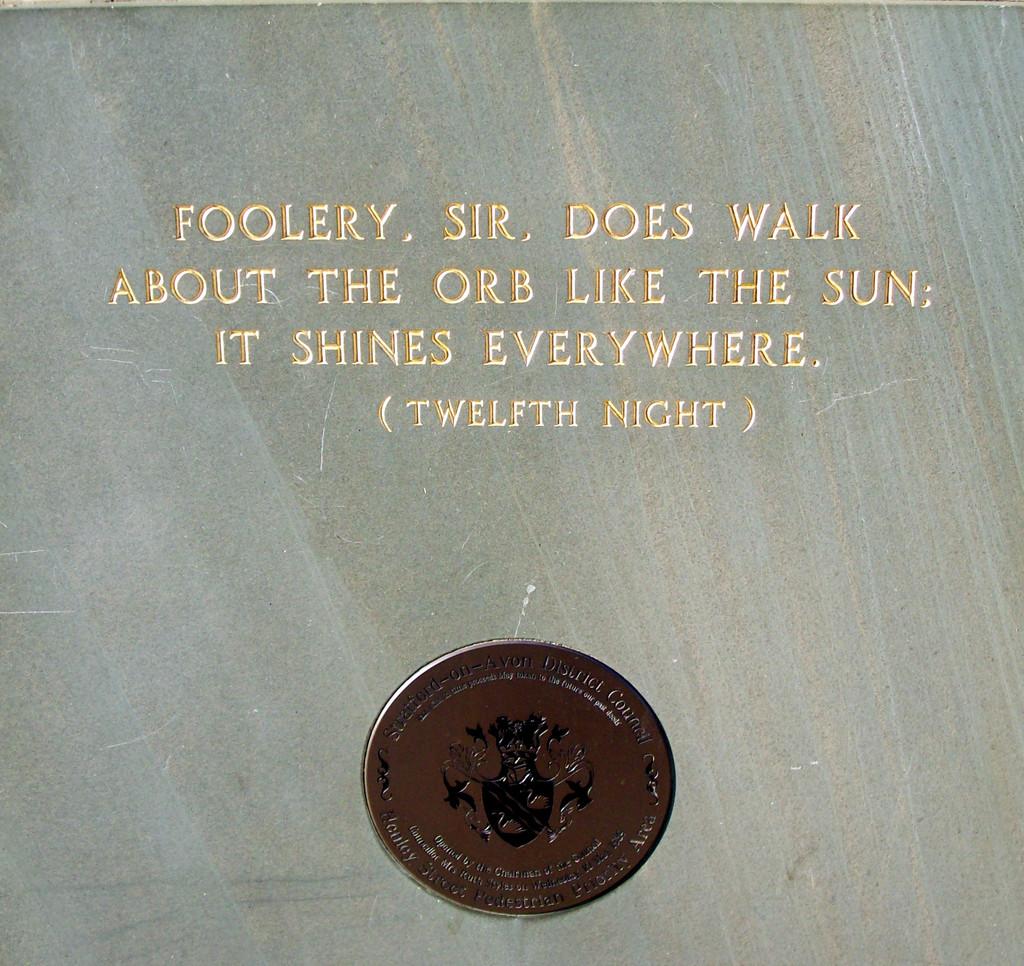Which night is it?
Offer a terse response. Twelfth. 